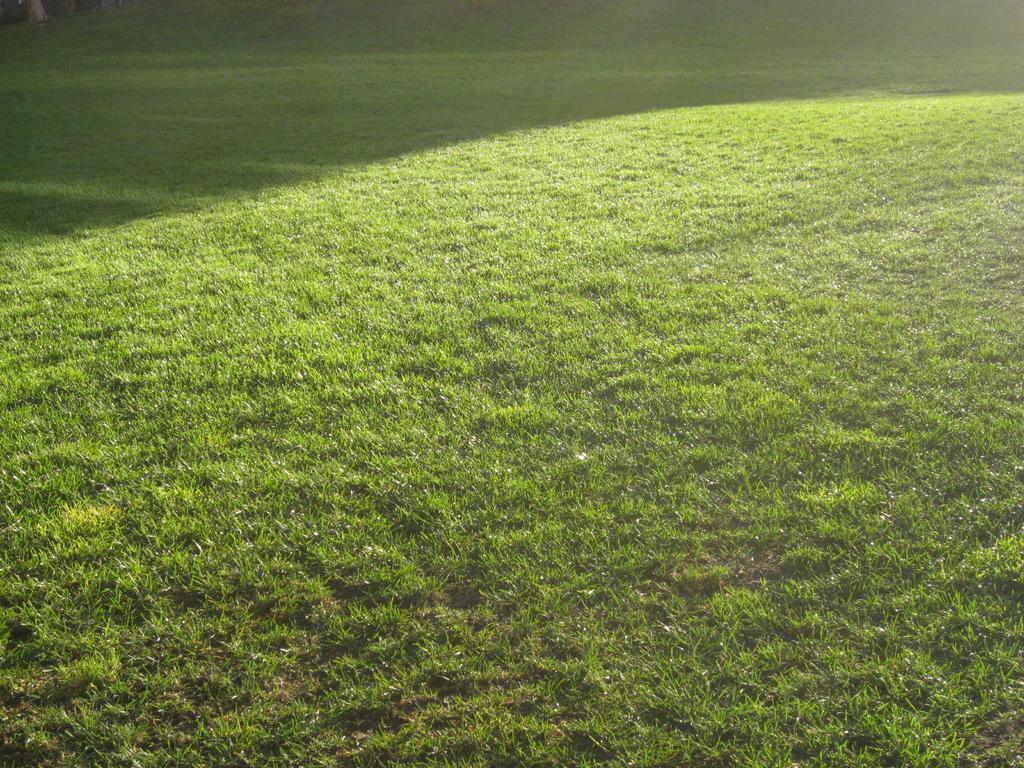Could you give a brief overview of what you see in this image? In this image I can see the grass in green color. 